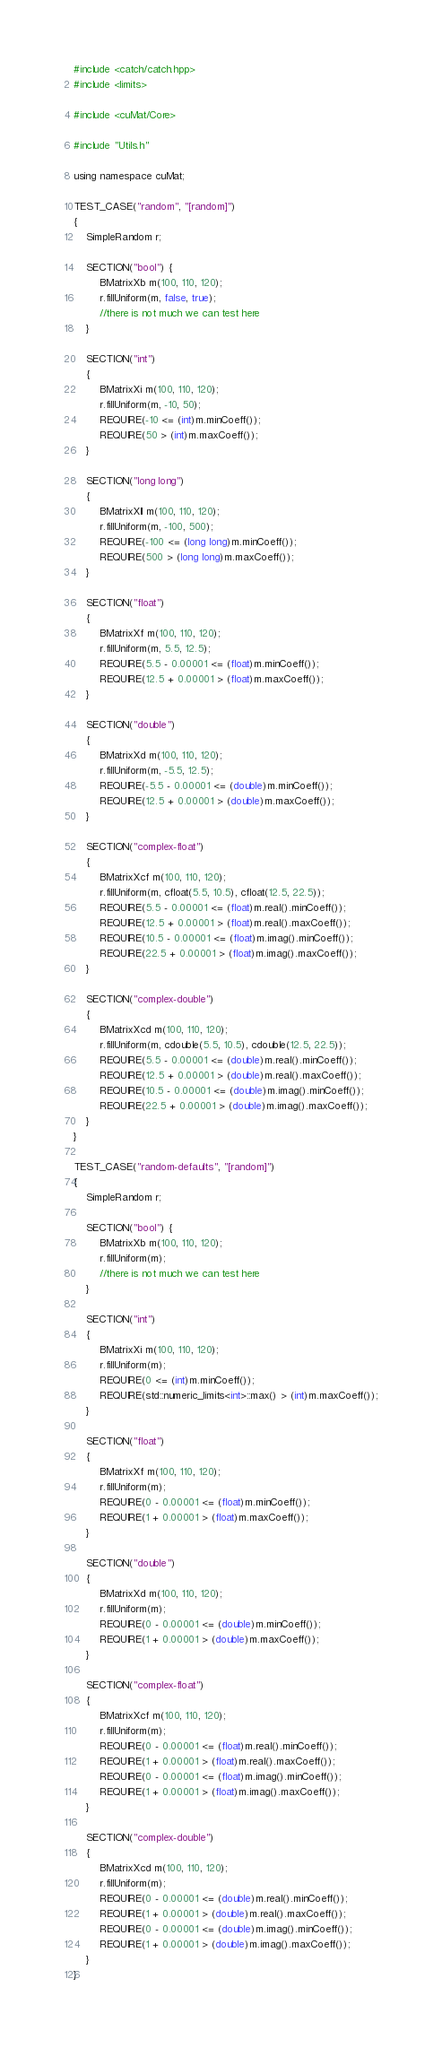Convert code to text. <code><loc_0><loc_0><loc_500><loc_500><_Cuda_>#include <catch/catch.hpp>
#include <limits>

#include <cuMat/Core>

#include "Utils.h"

using namespace cuMat;

TEST_CASE("random", "[random]")
{
    SimpleRandom r;

    SECTION("bool") {
        BMatrixXb m(100, 110, 120);
        r.fillUniform(m, false, true);
        //there is not much we can test here
    }

    SECTION("int")
    {
        BMatrixXi m(100, 110, 120);
        r.fillUniform(m, -10, 50);
        REQUIRE(-10 <= (int)m.minCoeff());
        REQUIRE(50 > (int)m.maxCoeff());
    }

    SECTION("long long")
    {
        BMatrixXll m(100, 110, 120);
        r.fillUniform(m, -100, 500);
        REQUIRE(-100 <= (long long)m.minCoeff());
        REQUIRE(500 > (long long)m.maxCoeff());
    }

    SECTION("float")
    {
        BMatrixXf m(100, 110, 120);
        r.fillUniform(m, 5.5, 12.5);
        REQUIRE(5.5 - 0.00001 <= (float)m.minCoeff());
        REQUIRE(12.5 + 0.00001 > (float)m.maxCoeff());
    }

    SECTION("double")
    {
        BMatrixXd m(100, 110, 120);
        r.fillUniform(m, -5.5, 12.5);
        REQUIRE(-5.5 - 0.00001 <= (double)m.minCoeff());
        REQUIRE(12.5 + 0.00001 > (double)m.maxCoeff());
    }

    SECTION("complex-float")
    {
        BMatrixXcf m(100, 110, 120);
        r.fillUniform(m, cfloat(5.5, 10.5), cfloat(12.5, 22.5));
        REQUIRE(5.5 - 0.00001 <= (float)m.real().minCoeff());
        REQUIRE(12.5 + 0.00001 > (float)m.real().maxCoeff());
        REQUIRE(10.5 - 0.00001 <= (float)m.imag().minCoeff());
        REQUIRE(22.5 + 0.00001 > (float)m.imag().maxCoeff());
    }

    SECTION("complex-double")
    {
        BMatrixXcd m(100, 110, 120);
        r.fillUniform(m, cdouble(5.5, 10.5), cdouble(12.5, 22.5));
        REQUIRE(5.5 - 0.00001 <= (double)m.real().minCoeff());
        REQUIRE(12.5 + 0.00001 > (double)m.real().maxCoeff());
        REQUIRE(10.5 - 0.00001 <= (double)m.imag().minCoeff());
        REQUIRE(22.5 + 0.00001 > (double)m.imag().maxCoeff());
    }
}

TEST_CASE("random-defaults", "[random]")
{
    SimpleRandom r;

    SECTION("bool") {
        BMatrixXb m(100, 110, 120);
        r.fillUniform(m);
        //there is not much we can test here
    }

    SECTION("int")
    {
        BMatrixXi m(100, 110, 120);
        r.fillUniform(m);
        REQUIRE(0 <= (int)m.minCoeff());
        REQUIRE(std::numeric_limits<int>::max() > (int)m.maxCoeff());
    }

    SECTION("float")
    {
        BMatrixXf m(100, 110, 120);
        r.fillUniform(m);
        REQUIRE(0 - 0.00001 <= (float)m.minCoeff());
        REQUIRE(1 + 0.00001 > (float)m.maxCoeff());
    }

    SECTION("double")
    {
        BMatrixXd m(100, 110, 120);
        r.fillUniform(m);
        REQUIRE(0 - 0.00001 <= (double)m.minCoeff());
        REQUIRE(1 + 0.00001 > (double)m.maxCoeff());
    }

    SECTION("complex-float")
    {
        BMatrixXcf m(100, 110, 120);
        r.fillUniform(m);
        REQUIRE(0 - 0.00001 <= (float)m.real().minCoeff());
        REQUIRE(1 + 0.00001 > (float)m.real().maxCoeff());
        REQUIRE(0 - 0.00001 <= (float)m.imag().minCoeff());
        REQUIRE(1 + 0.00001 > (float)m.imag().maxCoeff());
    }

    SECTION("complex-double")
    {
        BMatrixXcd m(100, 110, 120);
        r.fillUniform(m);
        REQUIRE(0 - 0.00001 <= (double)m.real().minCoeff());
        REQUIRE(1 + 0.00001 > (double)m.real().maxCoeff());
        REQUIRE(0 - 0.00001 <= (double)m.imag().minCoeff());
        REQUIRE(1 + 0.00001 > (double)m.imag().maxCoeff());
    }
}</code> 